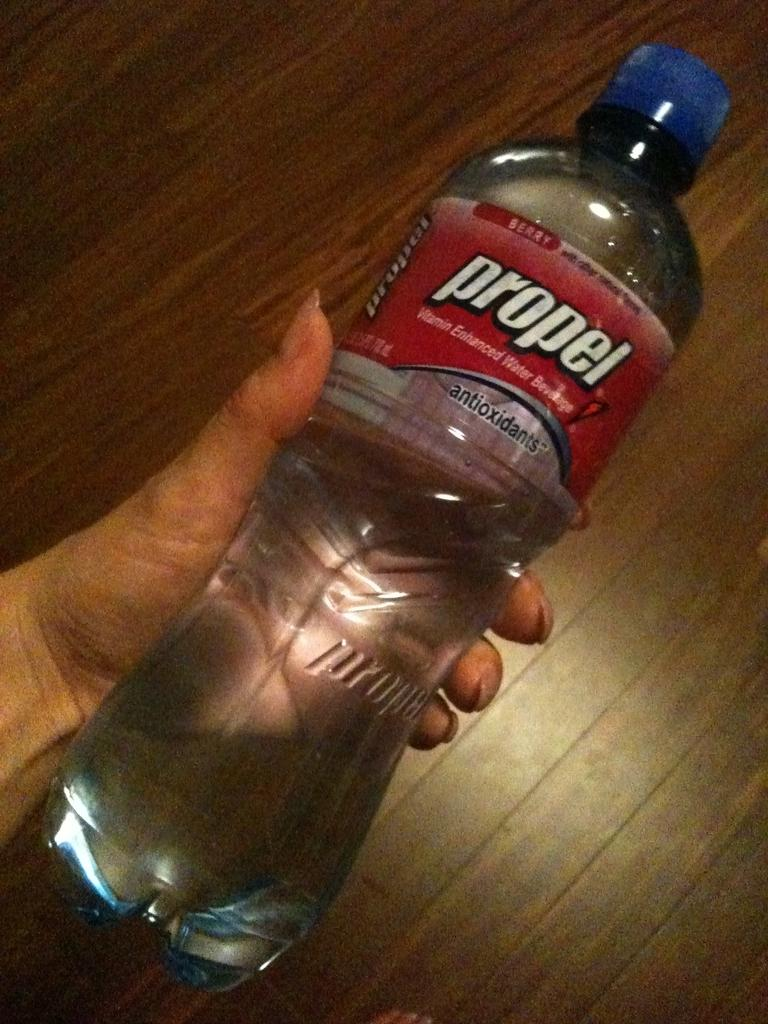What is the main subject of the image? The main subject of the image is a human hand. What is the hand holding in the image? The hand is holding a bottle. What type of jeans is the bucket wearing in the image? There is no bucket or jeans present in the image. 